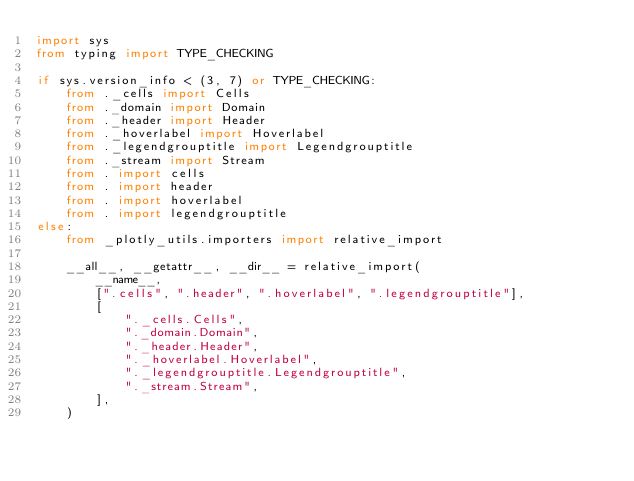Convert code to text. <code><loc_0><loc_0><loc_500><loc_500><_Python_>import sys
from typing import TYPE_CHECKING

if sys.version_info < (3, 7) or TYPE_CHECKING:
    from ._cells import Cells
    from ._domain import Domain
    from ._header import Header
    from ._hoverlabel import Hoverlabel
    from ._legendgrouptitle import Legendgrouptitle
    from ._stream import Stream
    from . import cells
    from . import header
    from . import hoverlabel
    from . import legendgrouptitle
else:
    from _plotly_utils.importers import relative_import

    __all__, __getattr__, __dir__ = relative_import(
        __name__,
        [".cells", ".header", ".hoverlabel", ".legendgrouptitle"],
        [
            "._cells.Cells",
            "._domain.Domain",
            "._header.Header",
            "._hoverlabel.Hoverlabel",
            "._legendgrouptitle.Legendgrouptitle",
            "._stream.Stream",
        ],
    )
</code> 